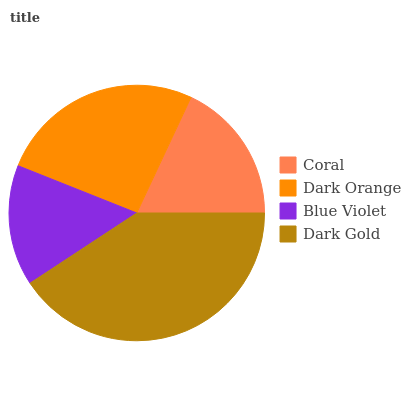Is Blue Violet the minimum?
Answer yes or no. Yes. Is Dark Gold the maximum?
Answer yes or no. Yes. Is Dark Orange the minimum?
Answer yes or no. No. Is Dark Orange the maximum?
Answer yes or no. No. Is Dark Orange greater than Coral?
Answer yes or no. Yes. Is Coral less than Dark Orange?
Answer yes or no. Yes. Is Coral greater than Dark Orange?
Answer yes or no. No. Is Dark Orange less than Coral?
Answer yes or no. No. Is Dark Orange the high median?
Answer yes or no. Yes. Is Coral the low median?
Answer yes or no. Yes. Is Dark Gold the high median?
Answer yes or no. No. Is Dark Orange the low median?
Answer yes or no. No. 